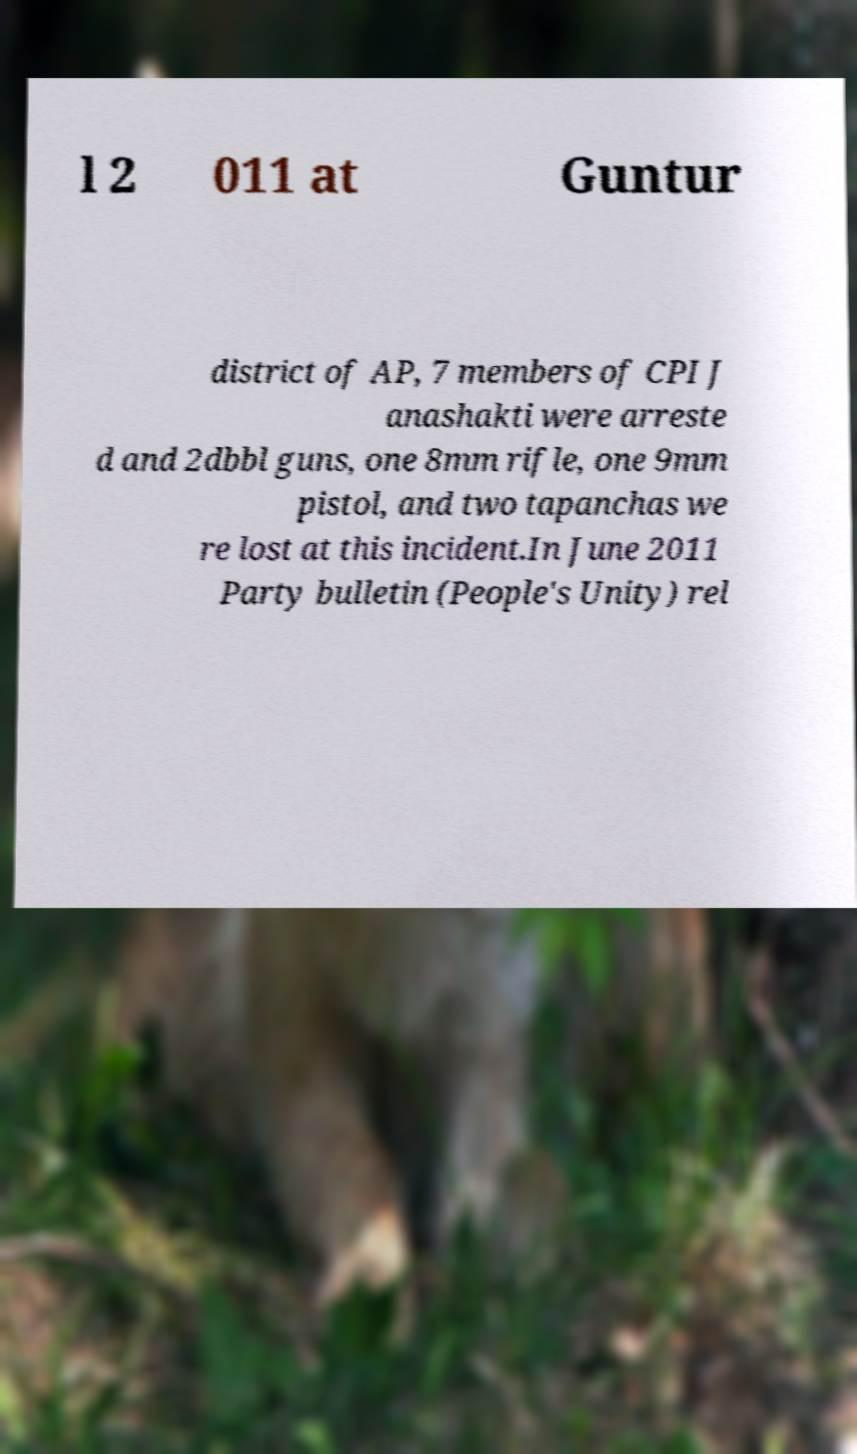Can you accurately transcribe the text from the provided image for me? l 2 011 at Guntur district of AP, 7 members of CPI J anashakti were arreste d and 2dbbl guns, one 8mm rifle, one 9mm pistol, and two tapanchas we re lost at this incident.In June 2011 Party bulletin (People's Unity) rel 